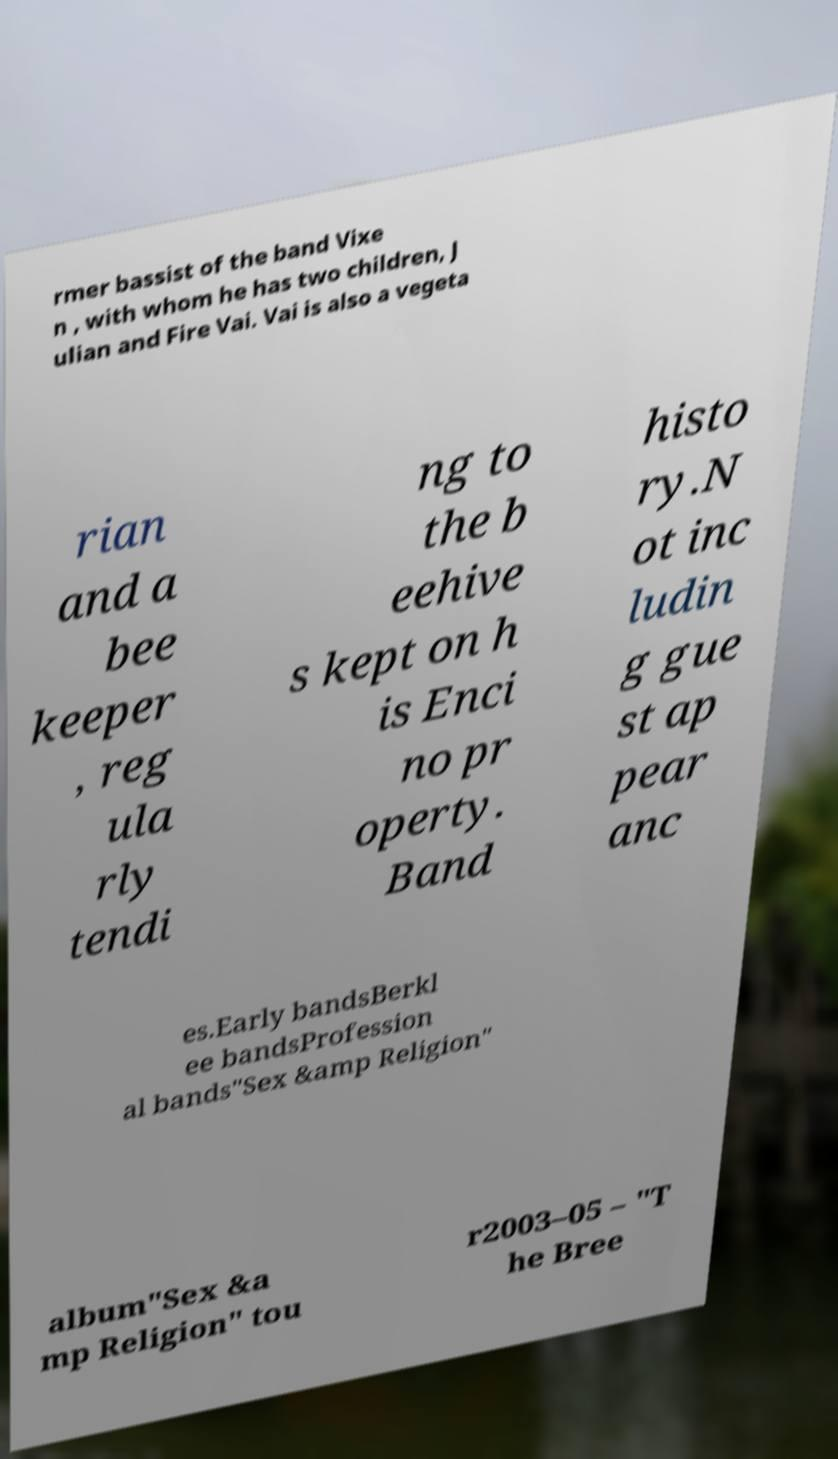I need the written content from this picture converted into text. Can you do that? rmer bassist of the band Vixe n , with whom he has two children, J ulian and Fire Vai. Vai is also a vegeta rian and a bee keeper , reg ula rly tendi ng to the b eehive s kept on h is Enci no pr operty. Band histo ry.N ot inc ludin g gue st ap pear anc es.Early bandsBerkl ee bandsProfession al bands"Sex &amp Religion" album"Sex &a mp Religion" tou r2003–05 – "T he Bree 